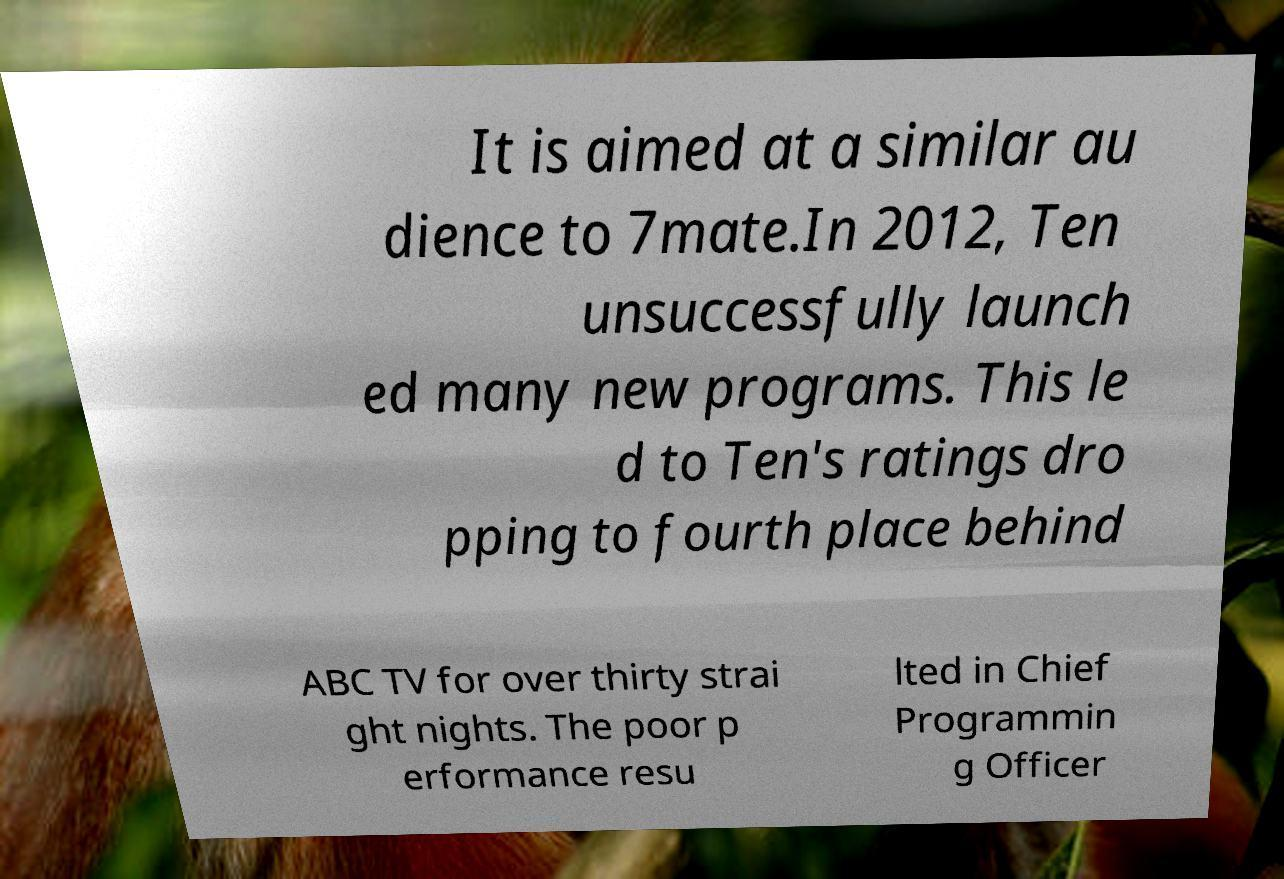Please identify and transcribe the text found in this image. It is aimed at a similar au dience to 7mate.In 2012, Ten unsuccessfully launch ed many new programs. This le d to Ten's ratings dro pping to fourth place behind ABC TV for over thirty strai ght nights. The poor p erformance resu lted in Chief Programmin g Officer 